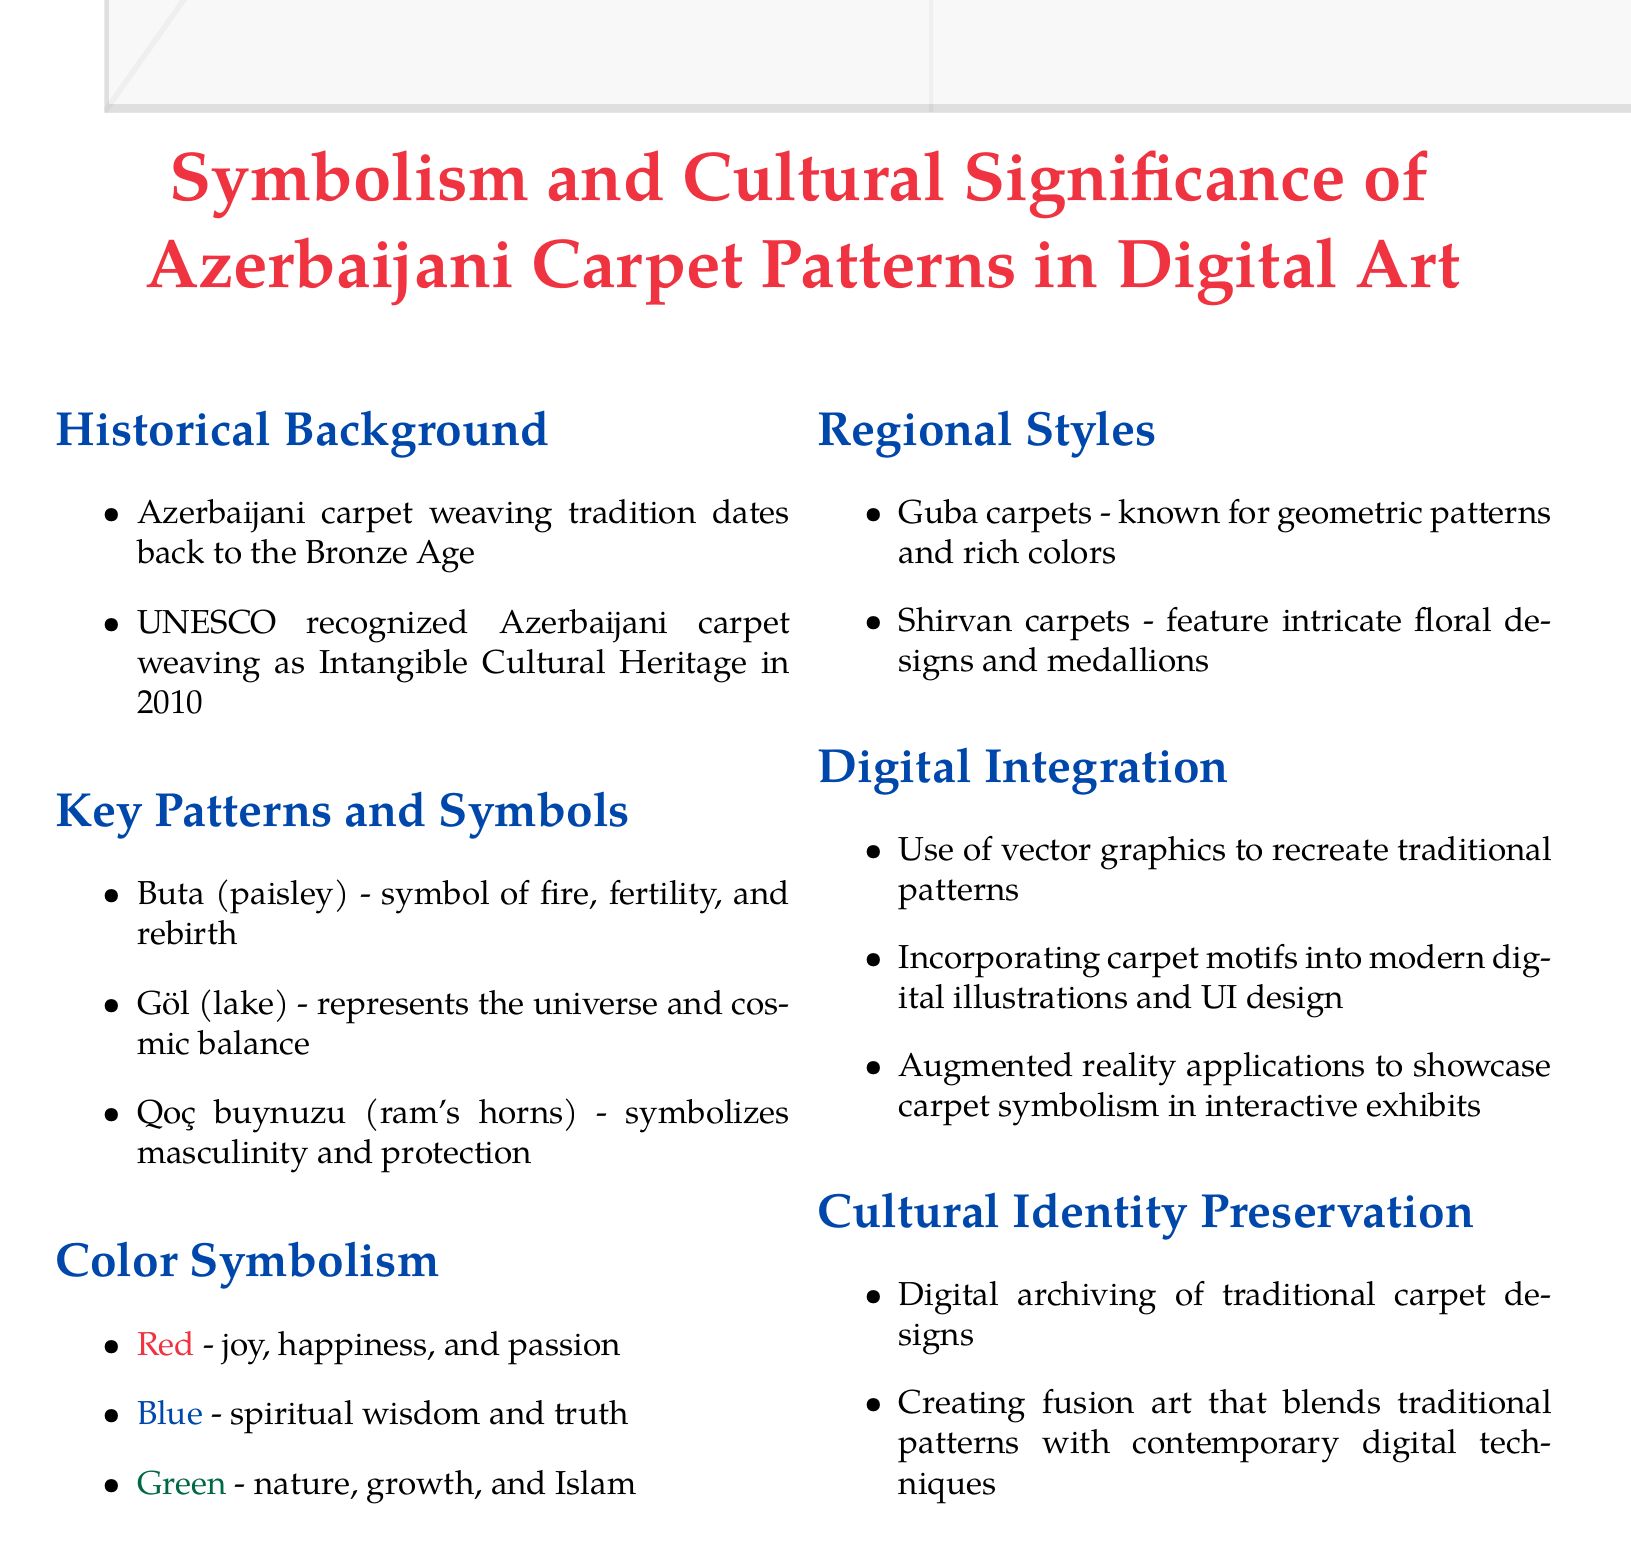What is the historical significance of Azerbaijani carpet weaving? The tradition dates back to the Bronze Age and was recognized as Intangible Cultural Heritage by UNESCO in 2010.
Answer: Bronze Age, UNESCO Intangible Cultural Heritage 2010 What does the Buta symbol represent? The Buta symbolizes fire, fertility, and rebirth.
Answer: Fire, fertility, rebirth What color represents spiritual wisdom in Azerbaijani carpet symbolism? The color blue represents spiritual wisdom and truth.
Answer: Blue Which two types of carpets are mentioned in the regional styles section? The document lists Guba carpets and Shirvan carpets as two regional styles.
Answer: Guba, Shirvan What is one method of integrating traditional patterns into digital art? One method is the use of vector graphics to recreate traditional patterns.
Answer: Vector graphics How are digital techniques used to preserve cultural identity? Digital archiving of traditional carpet designs preserves cultural identity.
Answer: Digital archiving What does the Qoç buynuzu symbolize? The Qoç buynuzu symbolizes masculinity and protection.
Answer: Masculinity, protection What year was Azerbaijani carpet weaving recognized by UNESCO? Azerbaijani carpet weaving was recognized in the year 2010.
Answer: 2010 What is a significant characteristic of Guba carpets? Guba carpets are known for geometric patterns and rich colors.
Answer: Geometric patterns, rich colors 